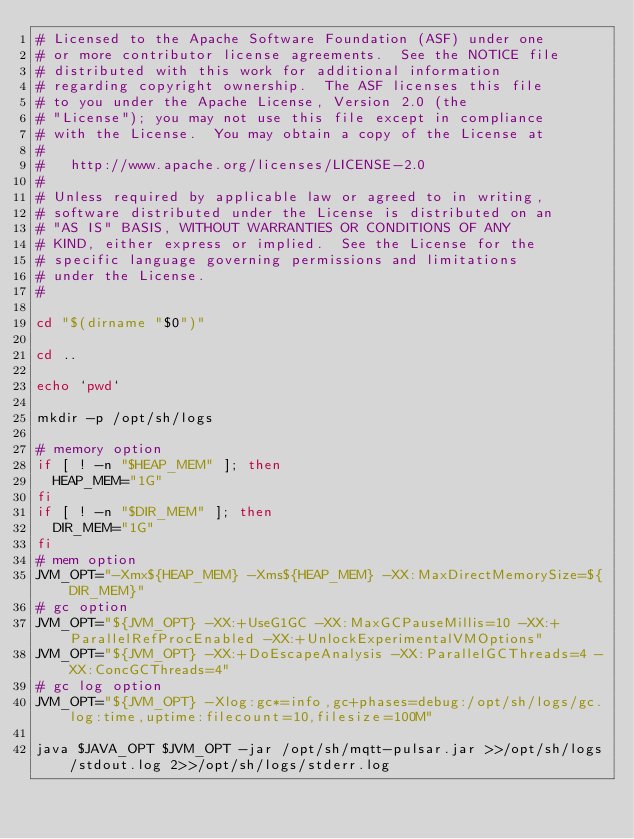<code> <loc_0><loc_0><loc_500><loc_500><_Bash_># Licensed to the Apache Software Foundation (ASF) under one
# or more contributor license agreements.  See the NOTICE file
# distributed with this work for additional information
# regarding copyright ownership.  The ASF licenses this file
# to you under the Apache License, Version 2.0 (the
# "License"); you may not use this file except in compliance
# with the License.  You may obtain a copy of the License at
#
#   http://www.apache.org/licenses/LICENSE-2.0
#
# Unless required by applicable law or agreed to in writing,
# software distributed under the License is distributed on an
# "AS IS" BASIS, WITHOUT WARRANTIES OR CONDITIONS OF ANY
# KIND, either express or implied.  See the License for the
# specific language governing permissions and limitations
# under the License.
#

cd "$(dirname "$0")"

cd ..

echo `pwd`

mkdir -p /opt/sh/logs

# memory option
if [ ! -n "$HEAP_MEM" ]; then
  HEAP_MEM="1G"
fi
if [ ! -n "$DIR_MEM" ]; then
  DIR_MEM="1G"
fi
# mem option
JVM_OPT="-Xmx${HEAP_MEM} -Xms${HEAP_MEM} -XX:MaxDirectMemorySize=${DIR_MEM}"
# gc option
JVM_OPT="${JVM_OPT} -XX:+UseG1GC -XX:MaxGCPauseMillis=10 -XX:+ParallelRefProcEnabled -XX:+UnlockExperimentalVMOptions"
JVM_OPT="${JVM_OPT} -XX:+DoEscapeAnalysis -XX:ParallelGCThreads=4 -XX:ConcGCThreads=4"
# gc log option
JVM_OPT="${JVM_OPT} -Xlog:gc*=info,gc+phases=debug:/opt/sh/logs/gc.log:time,uptime:filecount=10,filesize=100M"

java $JAVA_OPT $JVM_OPT -jar /opt/sh/mqtt-pulsar.jar >>/opt/sh/logs/stdout.log 2>>/opt/sh/logs/stderr.log
</code> 